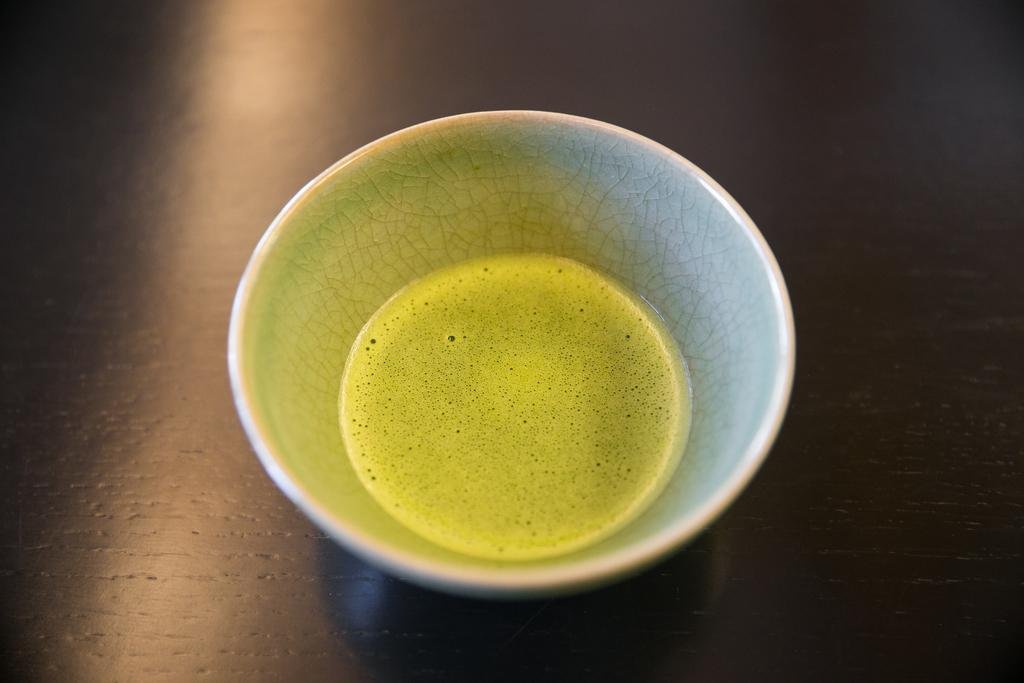What object is present on the wooden table in the image? There is a saucer on the wooden table in the image. What is the name of the person who created the saucer in the image? There is no information about the creator of the saucer in the image, nor is there any indication that the saucer was created by a person. 